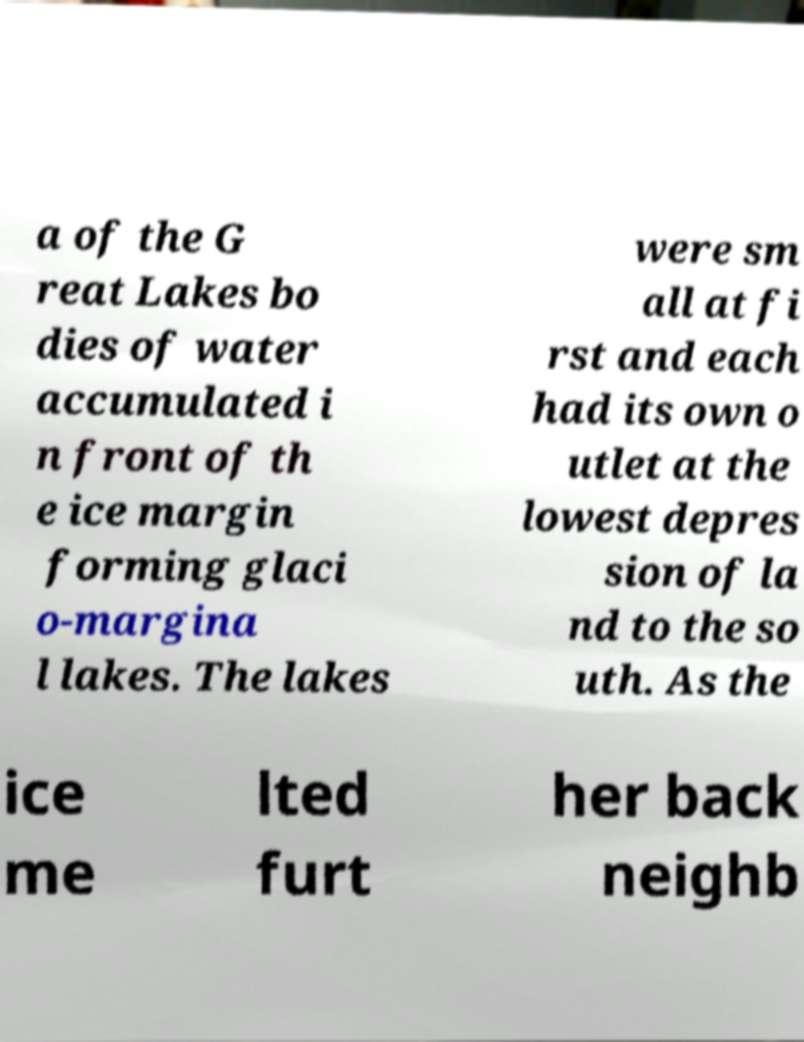What messages or text are displayed in this image? I need them in a readable, typed format. a of the G reat Lakes bo dies of water accumulated i n front of th e ice margin forming glaci o-margina l lakes. The lakes were sm all at fi rst and each had its own o utlet at the lowest depres sion of la nd to the so uth. As the ice me lted furt her back neighb 